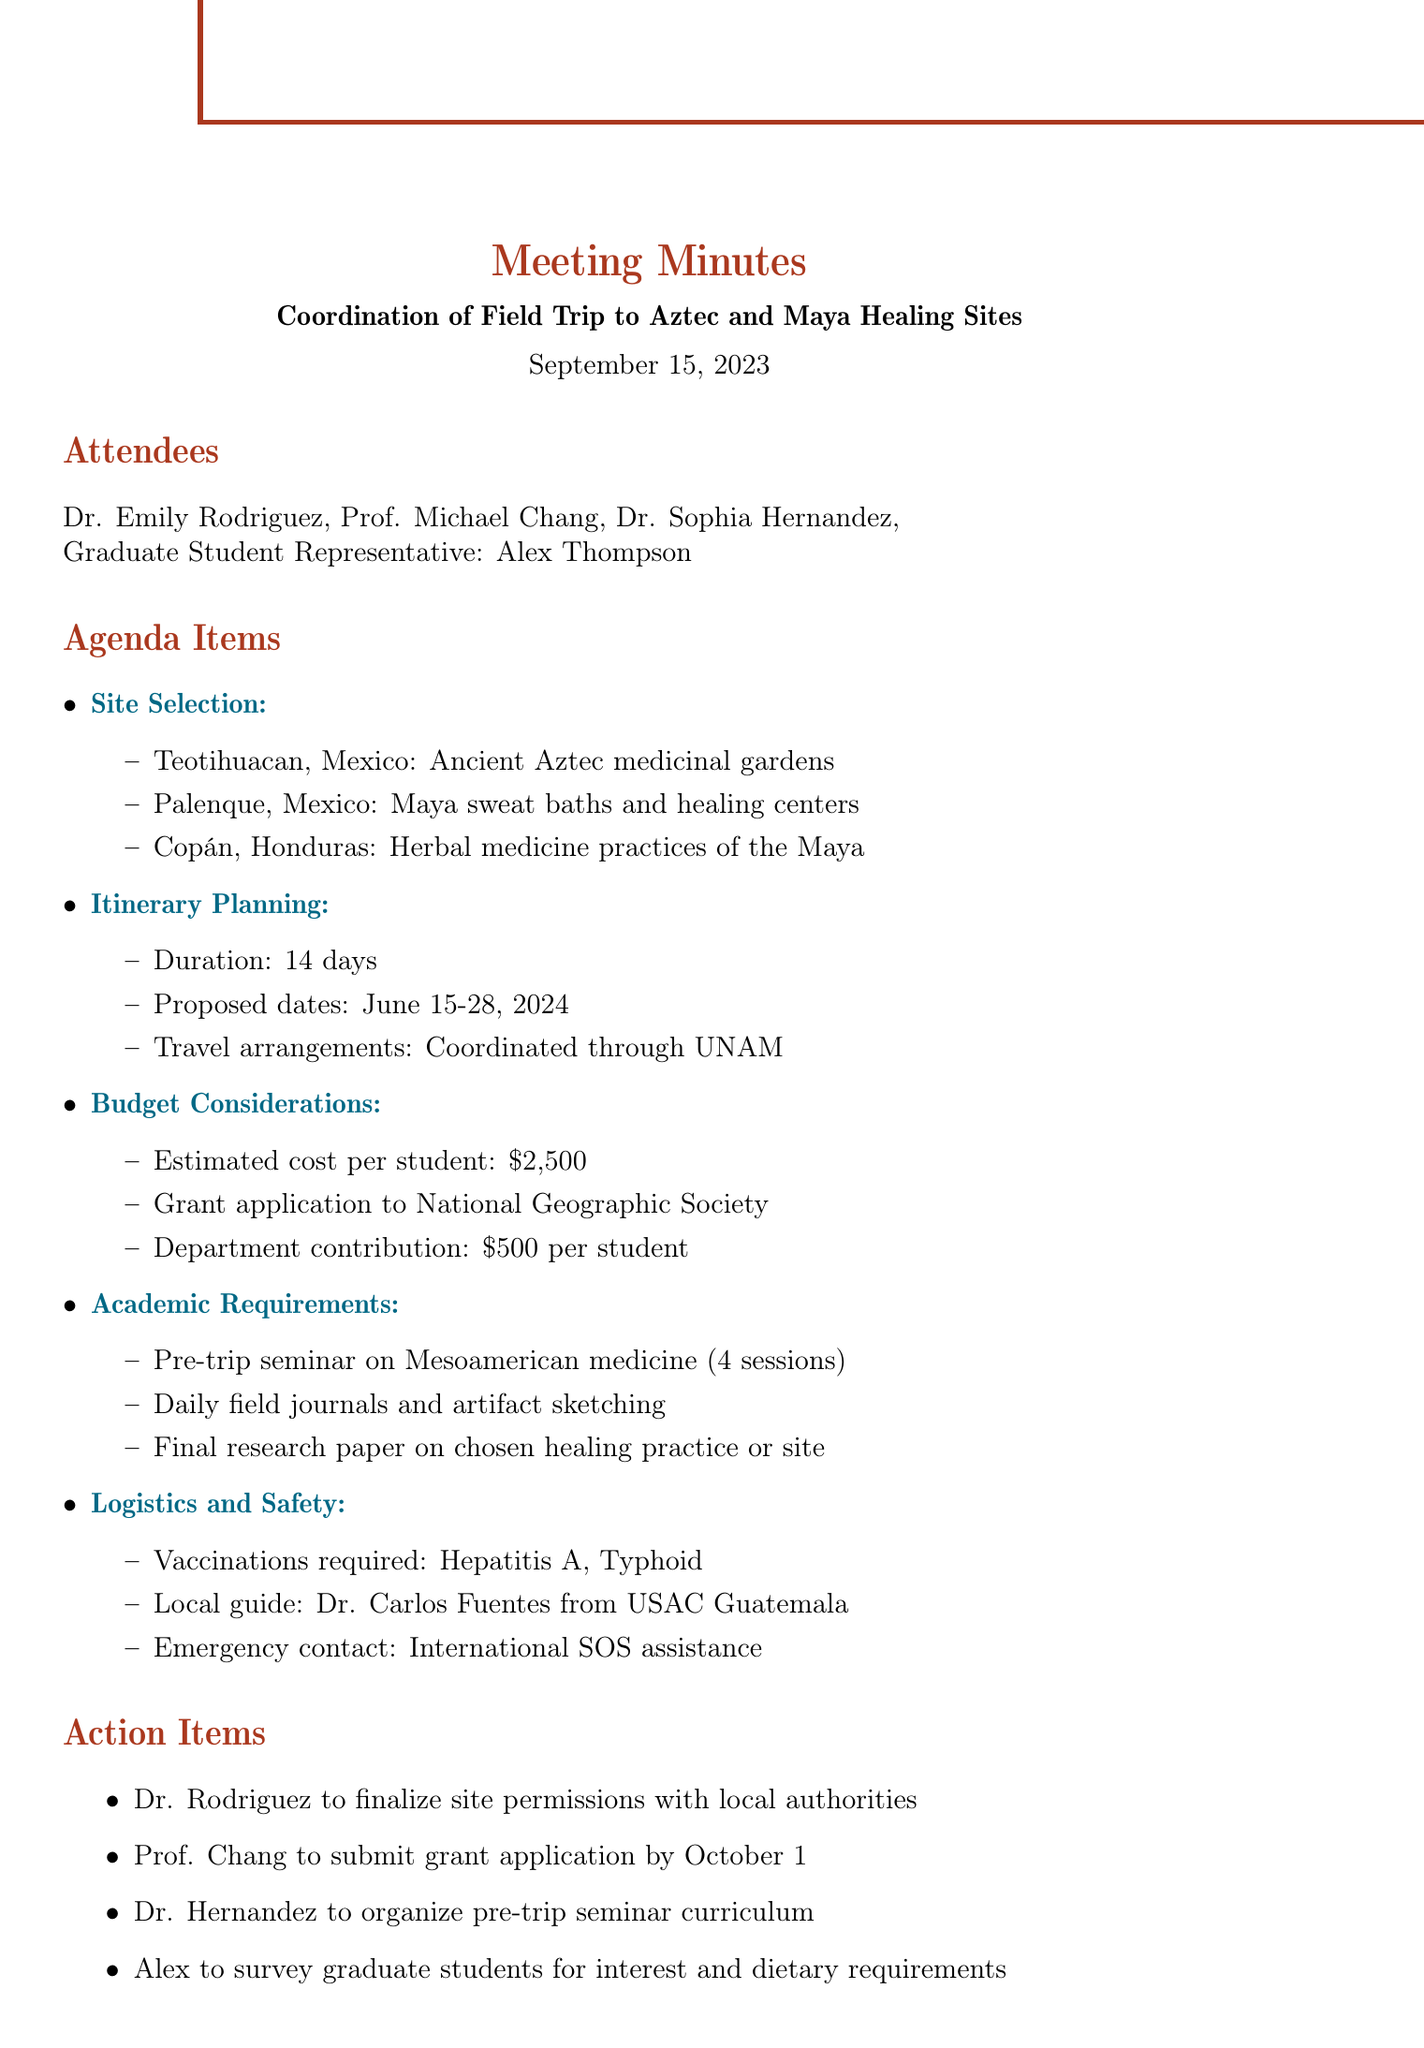What is the title of the meeting? The title of the meeting is clearly stated at the beginning of the document, which is "Coordination of Field Trip to Aztec and Maya Healing Sites."
Answer: Coordination of Field Trip to Aztec and Maya Healing Sites What are the proposed dates for the trip? The proposed dates for the trip are found under the Itinerary Planning section, which specifies the dates as June 15-28, 2024.
Answer: June 15-28, 2024 Who is the local guide for the trip? The local guide's name and affiliation are mentioned in the Logistics and Safety section, specifically indicating Dr. Carlos Fuentes from Universidad de San Carlos de Guatemala.
Answer: Dr. Carlos Fuentes What is the estimated cost per student? The estimated cost is listed in the Budget Considerations section, which states the cost as $2,500 per student.
Answer: $2,500 How many sessions will the pre-trip seminar include? The number of sessions for the pre-trip seminar is specified in the Academic Requirements section, which states it will consist of 4 sessions.
Answer: 4 sessions What action item is assigned to Dr. Hernandez? Dr. Hernandez's action item is listed in the Action Items section, which indicates that she is to organize the pre-trip seminar curriculum.
Answer: Organize pre-trip seminar curriculum What vaccinations are required? The required vaccinations are mentioned in the Logistics and Safety section, specifically noting Hepatitis A and Typhoid.
Answer: Hepatitis A, Typhoid What organization is the grant application submitted to? The organization for the grant application is provided in the Budget Considerations section, which states it is to the National Geographic Society.
Answer: National Geographic Society What is the duration of the field trip? The duration of the field trip is noted under Itinerary Planning, which specifies it will be for 14 days.
Answer: 14 days Who is the Graduate Student Representative in the meeting? The document lists the attendees and identifies the Graduate Student Representative as Alex Thompson.
Answer: Alex Thompson 